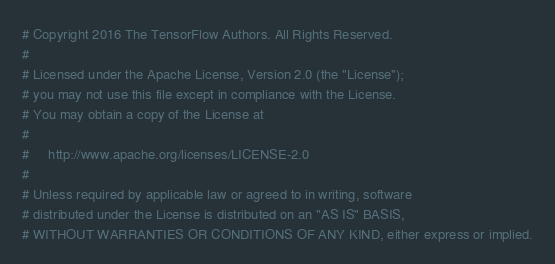<code> <loc_0><loc_0><loc_500><loc_500><_Python_># Copyright 2016 The TensorFlow Authors. All Rights Reserved.
#
# Licensed under the Apache License, Version 2.0 (the "License");
# you may not use this file except in compliance with the License.
# You may obtain a copy of the License at
#
#     http://www.apache.org/licenses/LICENSE-2.0
#
# Unless required by applicable law or agreed to in writing, software
# distributed under the License is distributed on an "AS IS" BASIS,
# WITHOUT WARRANTIES OR CONDITIONS OF ANY KIND, either express or implied.</code> 